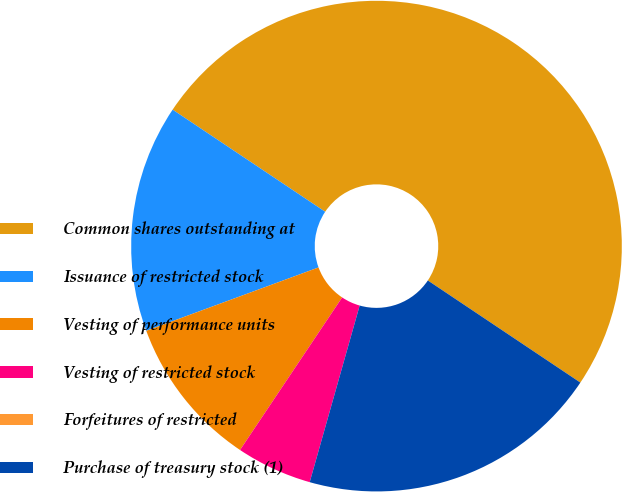Convert chart. <chart><loc_0><loc_0><loc_500><loc_500><pie_chart><fcel>Common shares outstanding at<fcel>Issuance of restricted stock<fcel>Vesting of performance units<fcel>Vesting of restricted stock<fcel>Forfeitures of restricted<fcel>Purchase of treasury stock (1)<nl><fcel>50.0%<fcel>15.0%<fcel>10.0%<fcel>5.0%<fcel>0.0%<fcel>20.0%<nl></chart> 